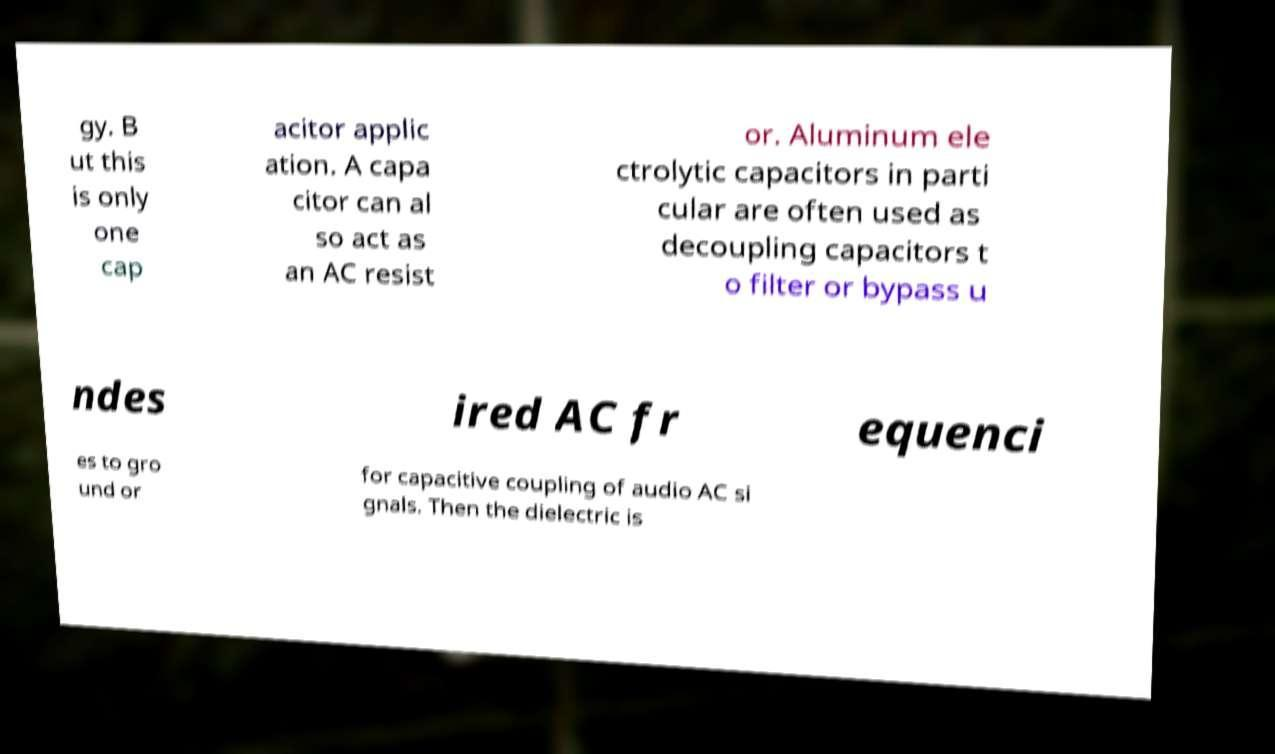Could you extract and type out the text from this image? gy. B ut this is only one cap acitor applic ation. A capa citor can al so act as an AC resist or. Aluminum ele ctrolytic capacitors in parti cular are often used as decoupling capacitors t o filter or bypass u ndes ired AC fr equenci es to gro und or for capacitive coupling of audio AC si gnals. Then the dielectric is 